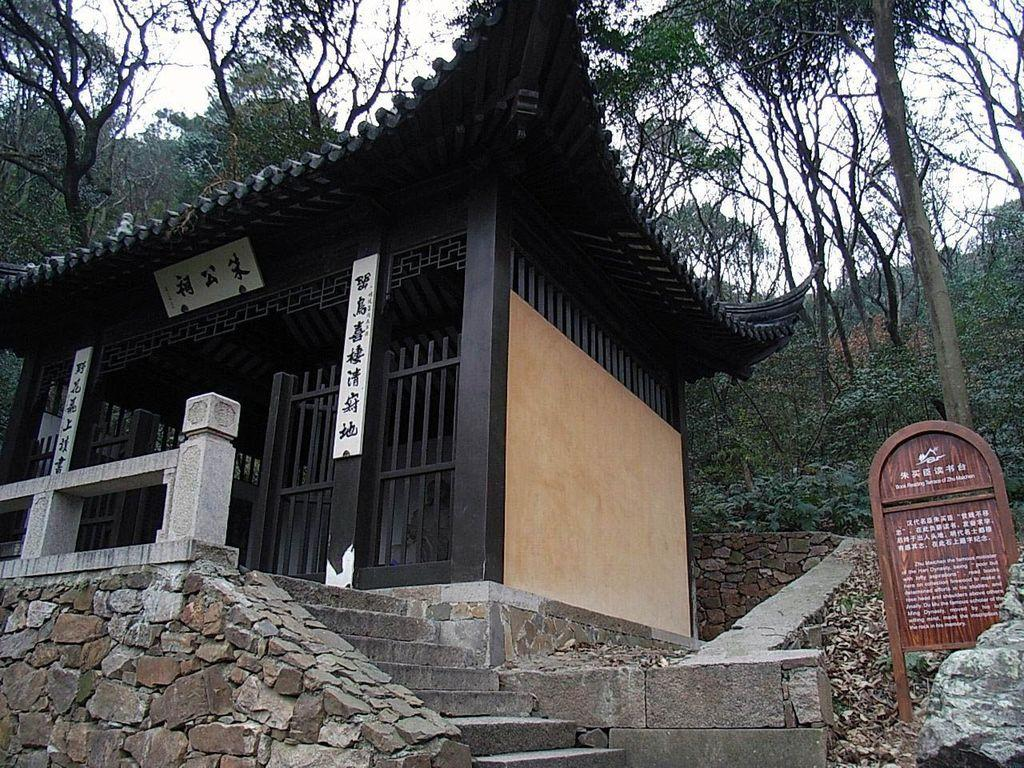What type of structure is present in the image? There is a house in the image. What architectural feature is visible in the image? There are stairs in the image. What type of vegetation is present in the image? There are plants and trees in the image. What part of the natural environment is visible in the image? The sky is visible in the image. What type of education can be seen being taught in the image? There is no indication of any educational activity taking place in the image. What color is the crayon used to draw the trees in the image? There is no crayon or drawing present in the image; it features real trees. 